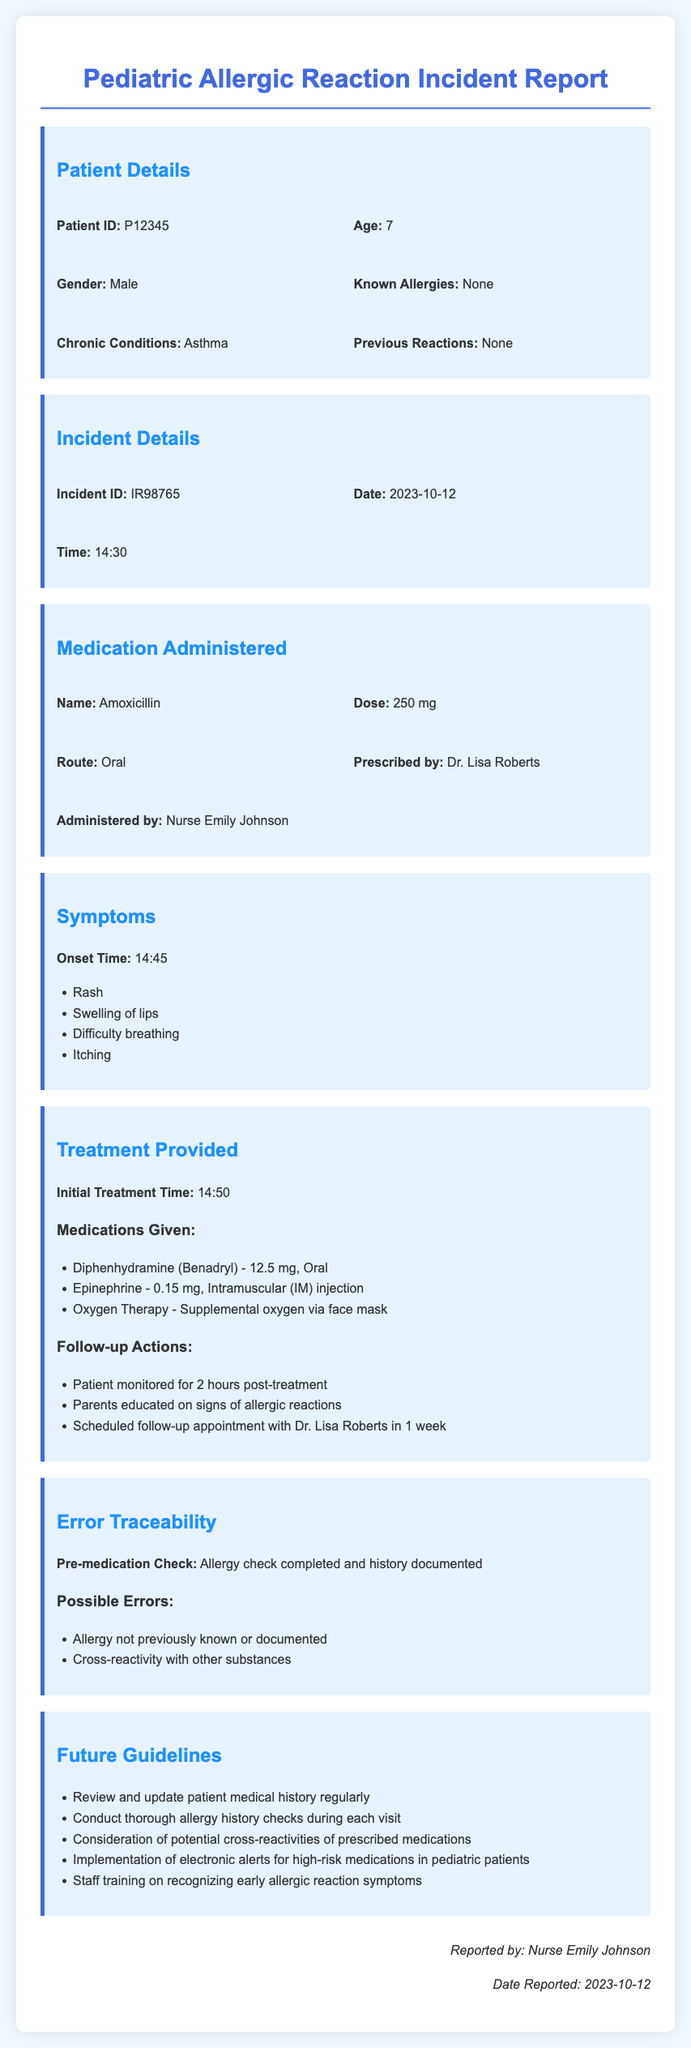What is the patient's age? The patient's age is provided in the patient details section of the report.
Answer: 7 What medication was administered? The name of the medication given to the patient is listed in the medication administered section.
Answer: Amoxicillin What time did the symptoms onset occur? The onset time of the symptoms is detailed in the symptoms section of the report.
Answer: 14:45 What is one symptom experienced by the patient? The symptoms experienced by the patient are listed in the symptoms section.
Answer: Rash What treatment was given initially? The initial treatment time and medications given are mentioned in the treatment provided section.
Answer: Diphenhydramine (Benadryl) What was the follow-up action taken after treatment? Follow-up actions after treatment are provided in the treatment section.
Answer: Parents educated on signs of allergic reactions What error was noted in the incident report? The possible errors regarding the allergic reaction are highlighted in the error traceability section.
Answer: Allergy not previously known or documented What guideline is recommended for future allergy checks? The future guidelines section provides recommendations for enhancing patient safety.
Answer: Conduct thorough allergy history checks during each visit Who reported the incident? The person who reported the incident is listed in the footer of the document.
Answer: Nurse Emily Johnson 